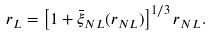Convert formula to latex. <formula><loc_0><loc_0><loc_500><loc_500>r _ { L } = \left [ 1 + \bar { \xi } _ { N L } ( r _ { N L } ) \right ] ^ { 1 / 3 } r _ { N L } .</formula> 